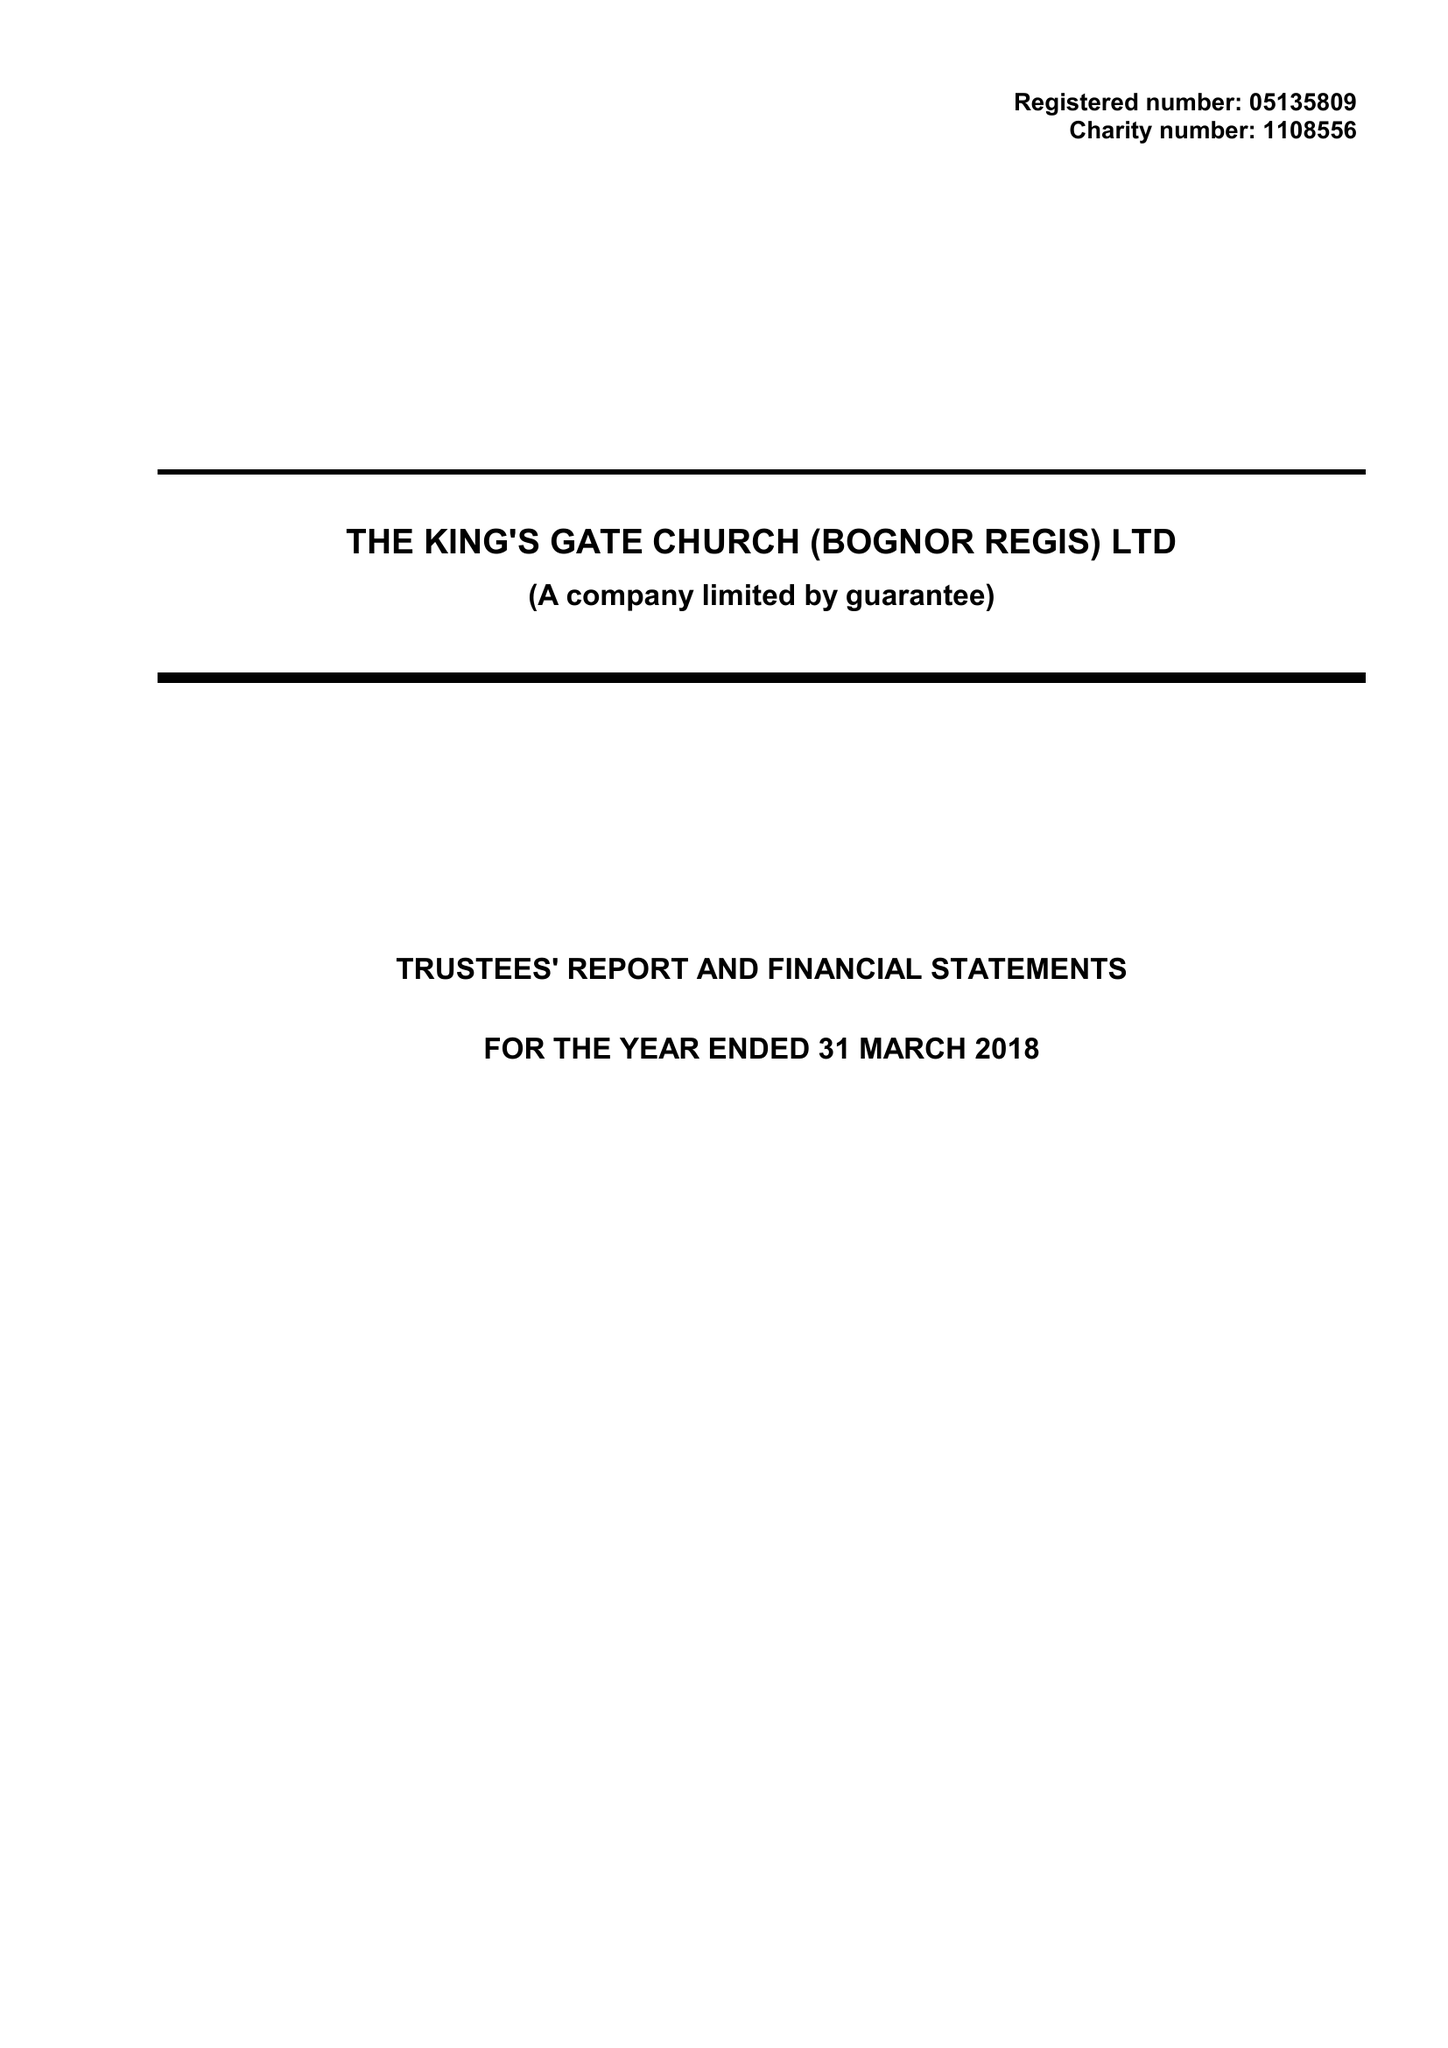What is the value for the address__postcode?
Answer the question using a single word or phrase. PO21 1BD 